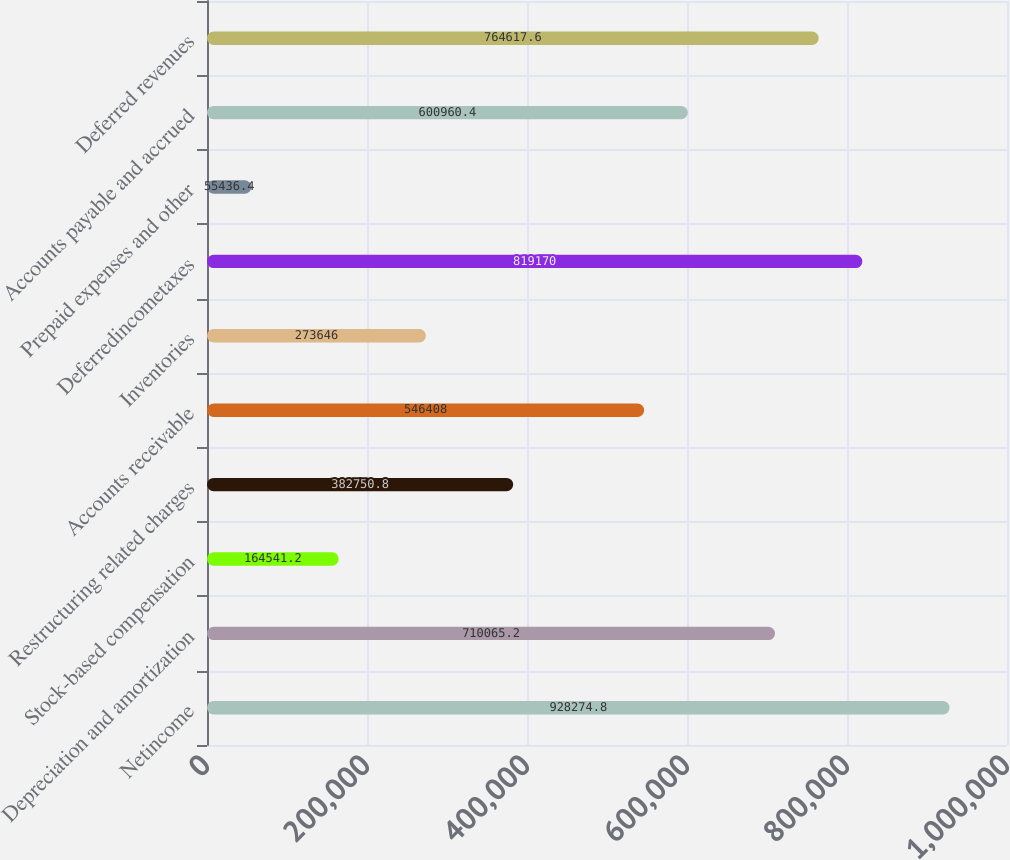Convert chart. <chart><loc_0><loc_0><loc_500><loc_500><bar_chart><fcel>Netincome<fcel>Depreciation and amortization<fcel>Stock-based compensation<fcel>Restructuring related charges<fcel>Accounts receivable<fcel>Inventories<fcel>Deferredincometaxes<fcel>Prepaid expenses and other<fcel>Accounts payable and accrued<fcel>Deferred revenues<nl><fcel>928275<fcel>710065<fcel>164541<fcel>382751<fcel>546408<fcel>273646<fcel>819170<fcel>55436.4<fcel>600960<fcel>764618<nl></chart> 